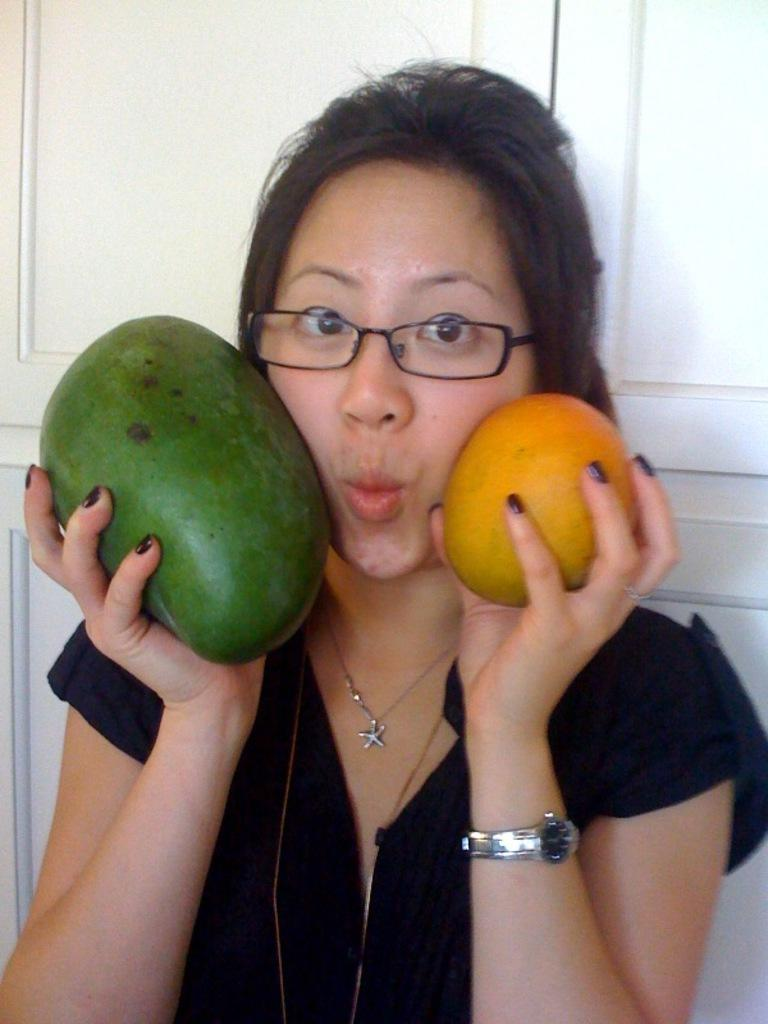What is the main subject of the image? There is a woman standing in the middle of the image. What is the woman holding in the image? The woman is holding two fruits. What can be seen behind the woman in the image? There is a wall visible behind the woman. What type of glove is the woman wearing in the image? There is no glove visible in the image; the woman is holding two fruits. Who is the manager of the woman in the image? There is no information about a manager in the image; it only shows a woman holding two fruits with a wall in the background. 